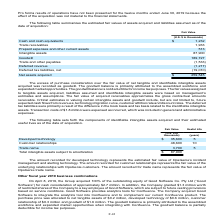According to Atlassian Plc's financial document, What does the amount recorded for developed technology represent? The estimated fair value of OpsGenie’s incident management and alerting technology. The document states: "ount recorded for developed technology represents the estimated fair value of OpsGenie’s incident management and alerting technology. The amount recor..." Also, What does the amount recorded for customer relationships represent? The fair value of the underlying relationships with OpsGenie customers. The document states: "nt recorded for customer relationships represents the fair value of the underlying relationships with OpsGenie customers. The amount recorded for trad..." Also, What is the useful life for Developed technology? According to the financial document, 5. The relevant text states: "Prepaid expenses and other current assets 513..." Also, can you calculate: What is the difference in useful life between developed technology and customer relationships? Based on the calculation: 10-5, the result is 5. This is based on the information: "Customer relationships 48,600 10 Prepaid expenses and other current assets 513..." The key data points involved are: 10. Also, How many intangible assets have a useful life of more than 6 years? Based on the analysis, there are 1 instances. The counting process: Customer relationships. Also, can you calculate: What is the percentage constitution of customer relationships among the total intangible assets subject to amortization? Based on the calculation: 48,600/87,900, the result is 55.29 (percentage). This is based on the information: "Customer relationships 48,600 10 Intangible assets 87,900..." The key data points involved are: 48,600, 87,900. 